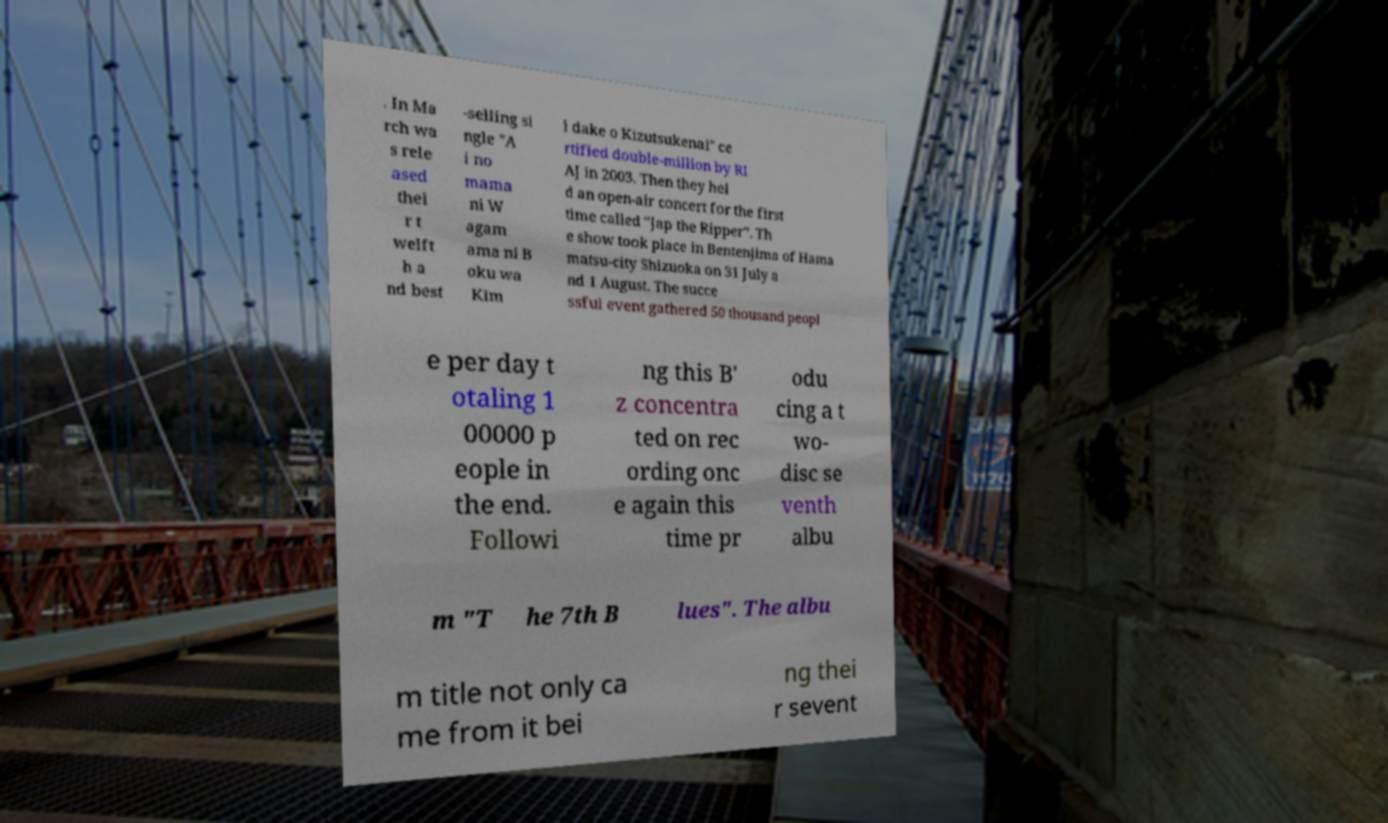Could you extract and type out the text from this image? . In Ma rch wa s rele ased thei r t welft h a nd best -selling si ngle "A i no mama ni W agam ama ni B oku wa Kim i dake o Kizutsukenai" ce rtified double-million by RI AJ in 2003. Then they hel d an open-air concert for the first time called "Jap the Ripper". Th e show took place in Bentenjima of Hama matsu-city Shizuoka on 31 July a nd 1 August. The succe ssful event gathered 50 thousand peopl e per day t otaling 1 00000 p eople in the end. Followi ng this B' z concentra ted on rec ording onc e again this time pr odu cing a t wo- disc se venth albu m "T he 7th B lues". The albu m title not only ca me from it bei ng thei r sevent 